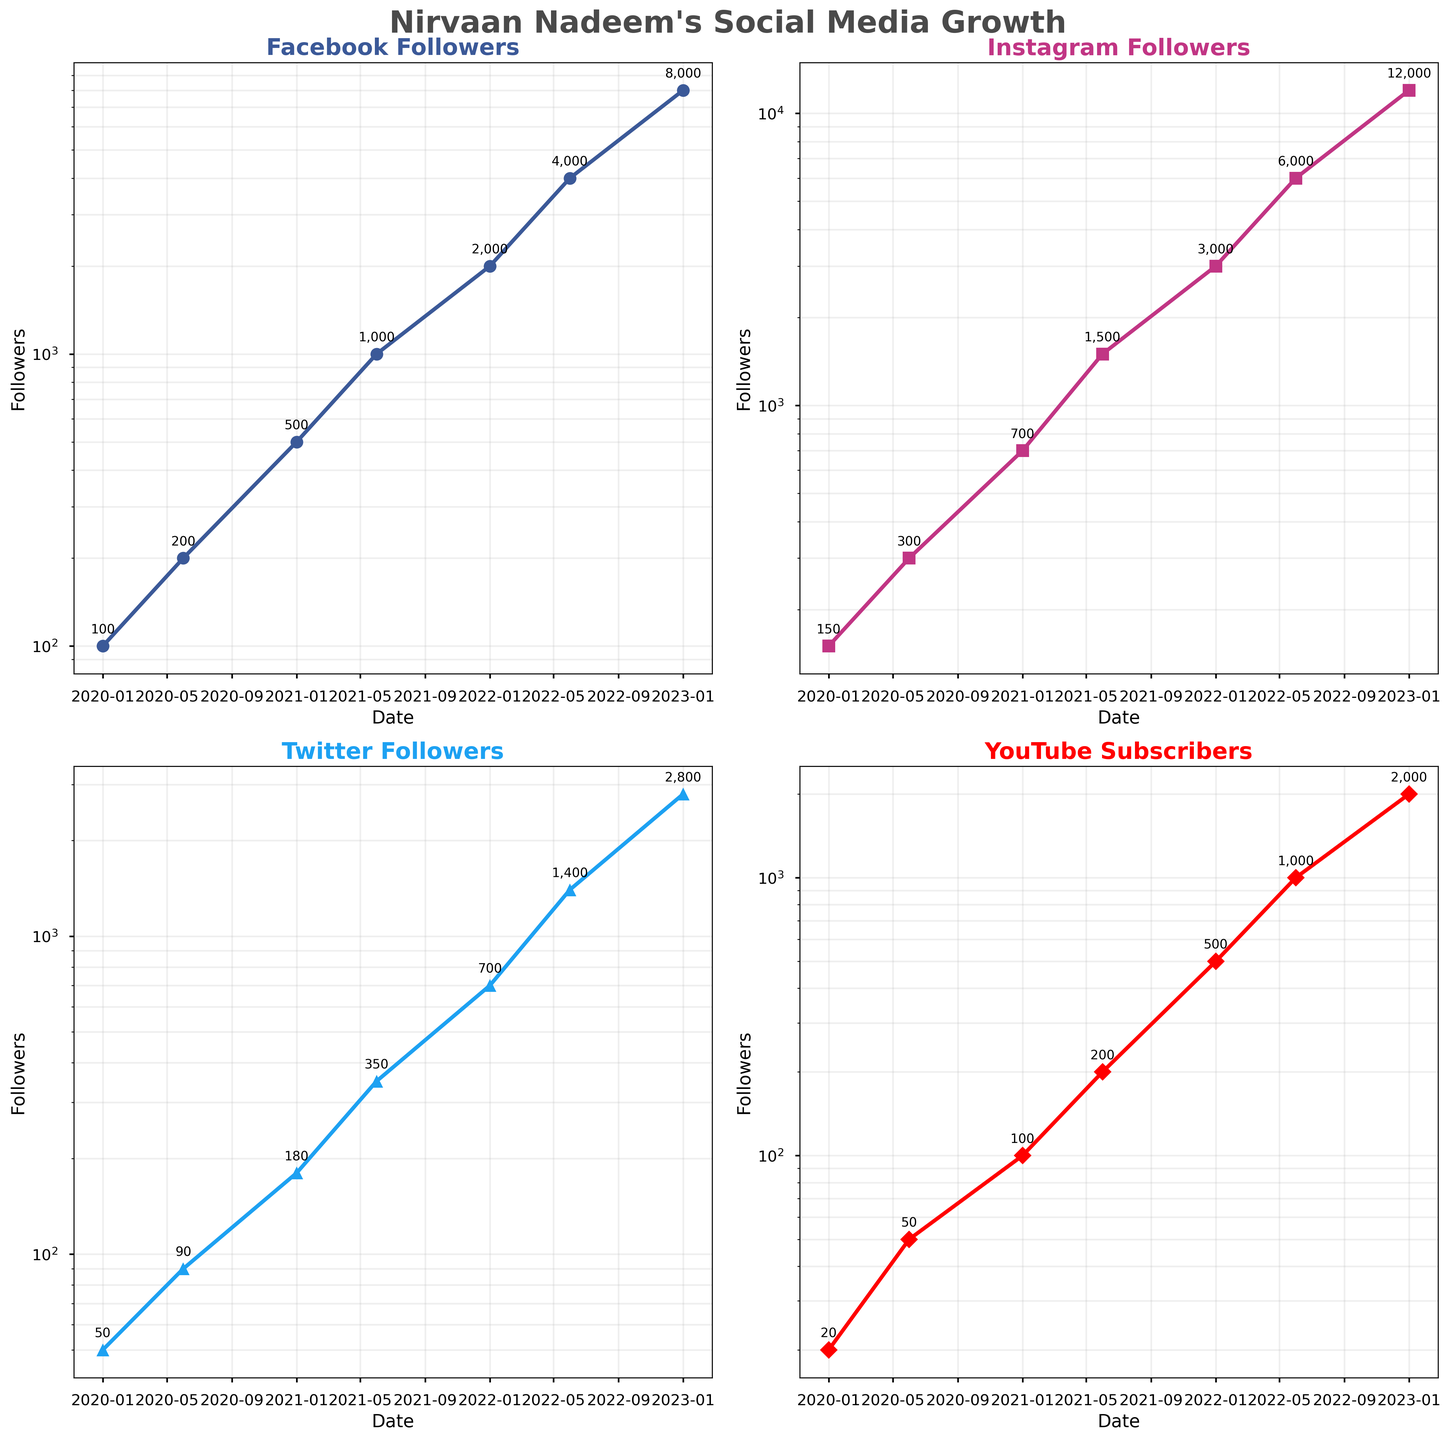What is the title of the figure? The title of the figure is usually located at the top, centered. By looking at this area, we can gather the specific name or subject of the visualization.
Answer: Nirvaan Nadeem's Social Media Growth Which social media platform had the highest number of followers on the last recorded date? This can be determined by checking the last data point (2023-01-01) on each subplot and noting the value with the highest follower count.
Answer: Instagram Followers How many times did YouTube Subscribers double over the recorded period? Observing the trend lines in the YouTube subplot over the different periods, calculate the occurrences where the count roughly doubled by visual inspection.
Answer: 6 times Between 2020-01-01 and 2022-06-01, which platform showed the highest overall growth in numbers? This involves subtracting the follower count at 2020-01-01 from the count at 2022-06-01 for each platform and identifying the platform with the largest increase.
Answer: Instagram Followers Comparing Twitter and Facebook, which platform had a higher compound annual growth rate (CAGR) from 2020-01-01 to 2023-01-01? To determine this, use the CAGR formula: [(End Value/Start Value)^(1/number of years)] - 1. The start and end values for each platform are extracted from their respective subplots.
Answer: Twitter What is the log scale used for the y-axis in each subplot? Observing each subplot, we can see how the y-values increase logarithmically, typically by factors of 10. This information denotes the visualization scale.
Answer: Logarithmic scale During which period did Facebook Followers grow the fastest? By examining the steepness of the slope in the line representing Facebook Followers, determine which interval has the steepest slope, showing the fastest growth.
Answer: 2020-06-01 to 2021-01-01 On 2021-06-01, how many more followers did Instagram have compared to Twitter? Look at the data points for 2021-06-01 in both the Instagram and Twitter subplots, then subtract the Twitter followers from the Instagram followers for that date.
Answer: 1150 more followers Which subplot shows the least growth over time? By comparing the overall slopes of each subplot, the subplot with the least steep overall slope demonstrates the least growth.
Answer: Twitter Followers Looking at the annotations, which was the first date when YouTube Subscribers reached 1000? Find the first date annotation in the YouTube subplot that equals or exceeds 1000. This indicates when the threshold was first achieved.
Answer: 2022-06-01 